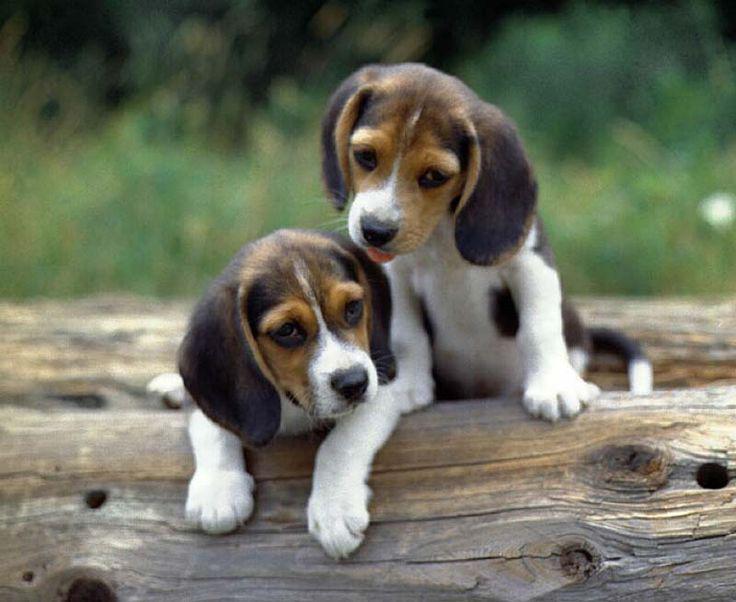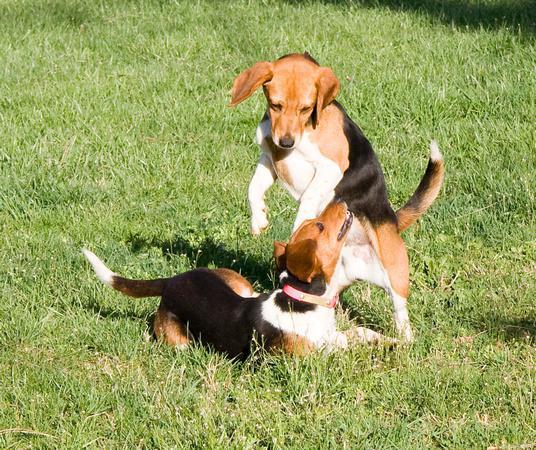The first image is the image on the left, the second image is the image on the right. Given the left and right images, does the statement "There are 3 or more puppies playing outside." hold true? Answer yes or no. Yes. The first image is the image on the left, the second image is the image on the right. For the images displayed, is the sentence "there is a dog  with a ball in its mouth on a grassy lawn" factually correct? Answer yes or no. No. 